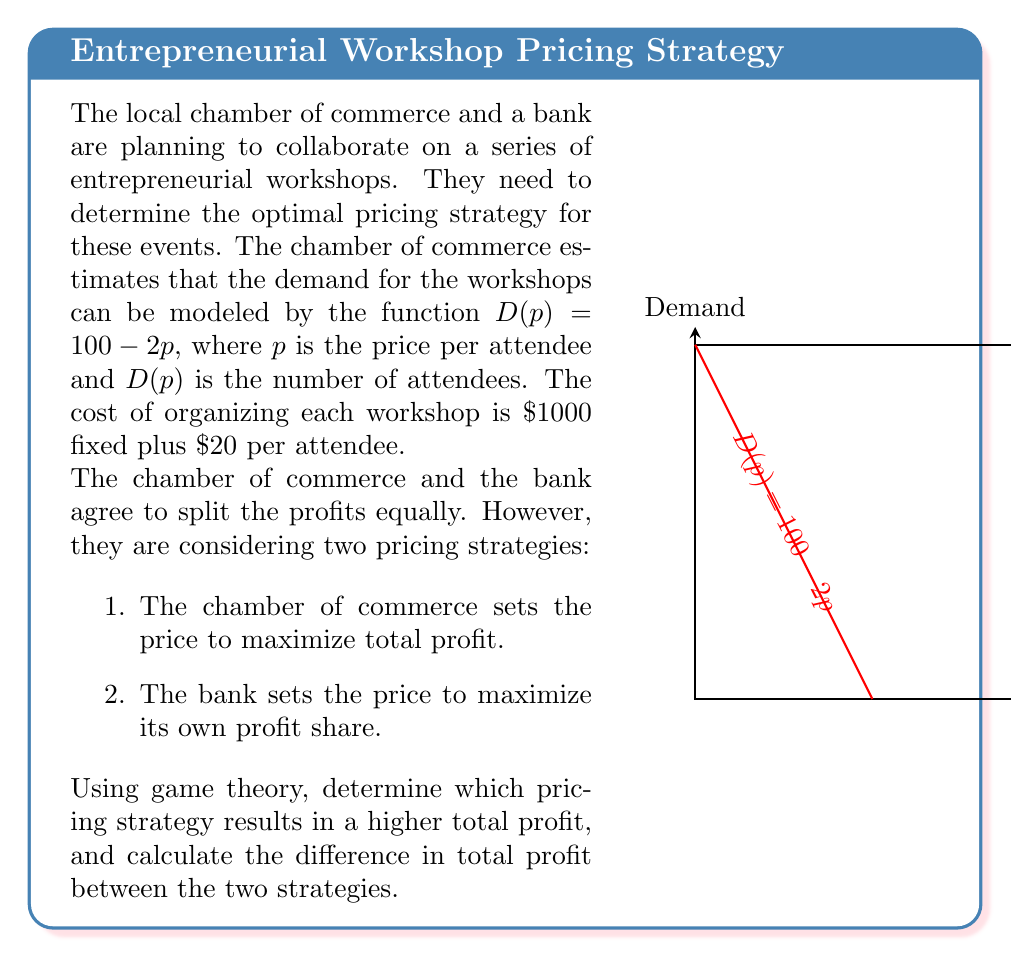What is the answer to this math problem? Let's approach this step-by-step:

1) First, let's define our profit function. Revenue is price times quantity: $R(p) = p \cdot D(p) = p(100-2p)$
   Cost is $1000 + 20D(p) = 1000 + 20(100-2p) = 3000 - 40p$
   So, the profit function is:
   $$\Pi(p) = R(p) - C(p) = p(100-2p) - (3000 - 40p) = 100p - 2p^2 - 3000 + 40p = -2p^2 + 140p - 3000$$

2) For strategy 1 (chamber of commerce maximizing total profit):
   To find the maximum, we differentiate and set to zero:
   $$\frac{d\Pi}{dp} = -4p + 140 = 0$$
   $$p = 35$$
   
   The second derivative is negative, confirming this is a maximum.
   At $p = 35$, $D(35) = 100 - 2(35) = 30$ attendees
   Total profit: $\Pi(35) = -2(35)^2 + 140(35) - 3000 = 450$

3) For strategy 2 (bank maximizing its own profit share):
   The bank's profit share is half of the total profit:
   $$\Pi_bank(p) = \frac{1}{2}(-2p^2 + 140p - 3000)$$
   
   Differentiating and setting to zero:
   $$\frac{d\Pi_bank}{dp} = -2p + 70 = 0$$
   $$p = 35$$
   
   Interestingly, this gives the same price as strategy 1.

4) Therefore, both strategies result in the same price and total profit.
   The difference in total profit between the two strategies is $0.

This result demonstrates a key principle in game theory: when parties have aligned interests (in this case, maximizing total profit which is then split equally), their individual optimal strategies align with the globally optimal strategy.
Answer: $0 (both strategies yield the same total profit) 